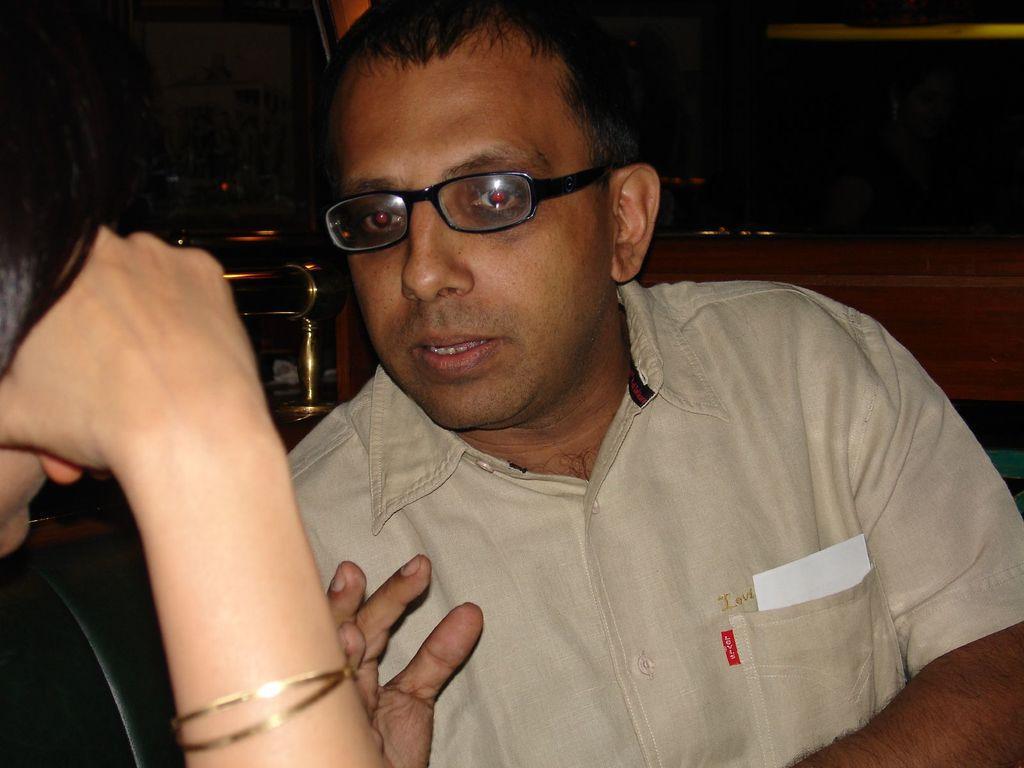Could you give a brief overview of what you see in this image? There is one person in the middle of this image is wearing spectacles. There is one other person on the left side of this image. It seems like there is a wooden thing in the background. 